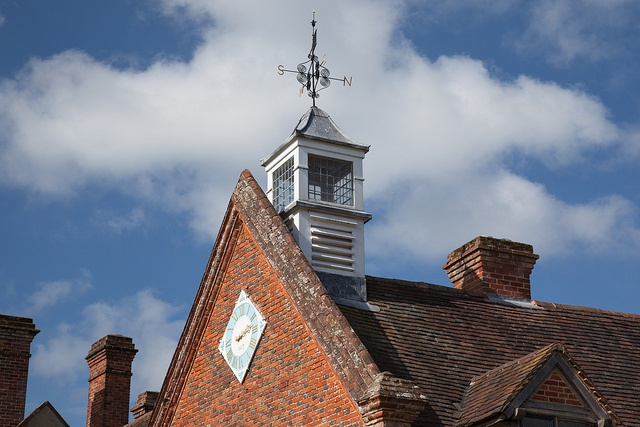Describe the objects in this image and their specific colors. I can see a clock in blue, white, lightblue, tan, and darkgray tones in this image. 